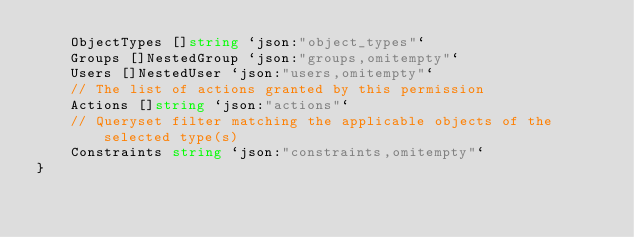Convert code to text. <code><loc_0><loc_0><loc_500><loc_500><_Go_>	ObjectTypes []string `json:"object_types"`
	Groups []NestedGroup `json:"groups,omitempty"`
	Users []NestedUser `json:"users,omitempty"`
	// The list of actions granted by this permission
	Actions []string `json:"actions"`
	// Queryset filter matching the applicable objects of the selected type(s)
	Constraints string `json:"constraints,omitempty"`
}
</code> 